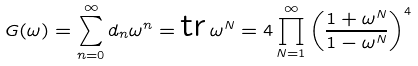Convert formula to latex. <formula><loc_0><loc_0><loc_500><loc_500>G ( \omega ) = \sum _ { n = 0 } ^ { \infty } d _ { n } \omega ^ { n } = \text {tr} \, \omega ^ { N } = 4 \prod _ { N = 1 } ^ { \infty } \left ( \frac { 1 + \omega ^ { N } } { 1 - \omega ^ { N } } \right ) ^ { 4 }</formula> 